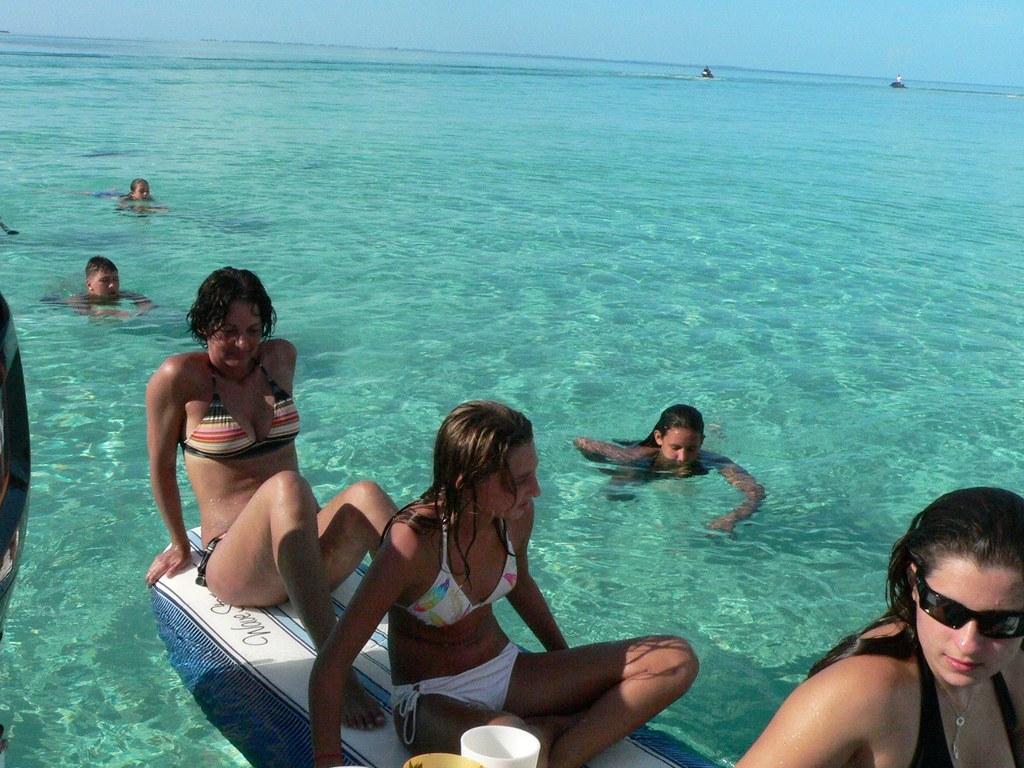Describe this image in one or two sentences. In this picture we can see two women sitting on a surfboard. There are few people visible in water. A woman is visible on boom right. We can see two people are seen on two boats. There is an object on left side. 